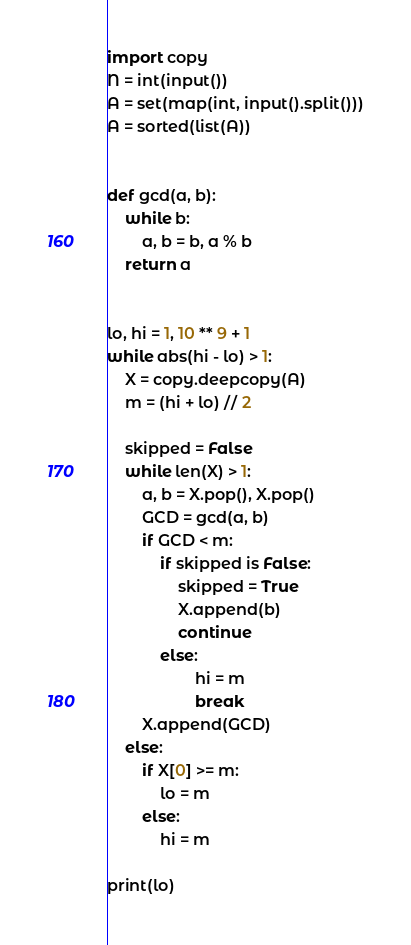<code> <loc_0><loc_0><loc_500><loc_500><_Python_>import copy
N = int(input())
A = set(map(int, input().split()))
A = sorted(list(A))


def gcd(a, b):
    while b:
        a, b = b, a % b
    return a


lo, hi = 1, 10 ** 9 + 1
while abs(hi - lo) > 1:
    X = copy.deepcopy(A)
    m = (hi + lo) // 2

    skipped = False
    while len(X) > 1:
        a, b = X.pop(), X.pop()
        GCD = gcd(a, b)
        if GCD < m:
            if skipped is False:
                skipped = True
                X.append(b)
                continue
            else:
                    hi = m
                    break
        X.append(GCD)
    else:
        if X[0] >= m:
            lo = m
        else:
            hi = m

print(lo)
</code> 